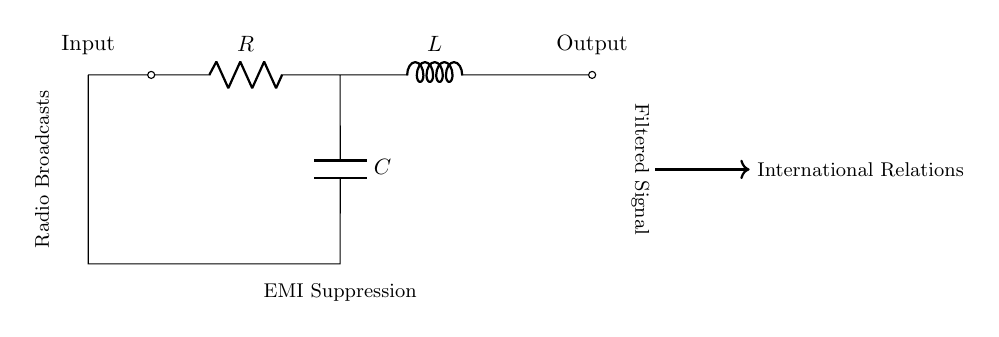What type of filter is represented in this circuit? The circuit diagram represents a low-pass filter, which allows low-frequency signals to pass while attenuating high-frequency signals, making it effective for reducing electromagnetic interference.
Answer: low-pass filter What components are present in the circuit? The circuit includes a resistor, inductor, and capacitor, which are the essential elements used to create a low-pass filter. Each plays a role in determining the filter's frequency characteristics.
Answer: resistor, inductor, capacitor What is the intended purpose of this circuit? The circuit is designed for EMI suppression, which refers to reducing electromagnetic interference in radio broadcasts related to international relations, ensuring clearer signal transmission.
Answer: EMI suppression Where does the filtered signal exit the circuit? The filtered signal exits on the right side of the diagram, shown at the output terminal, which is marked 'Output,' indicating where the processed signal can be taken for further use.
Answer: Output What effect does the inductor have in this filter? The inductor in the circuit opposes changes in current, which helps to block high-frequency signals from passing through, thereby facilitating the filter's ability to allow only low frequencies to pass.
Answer: block high-frequency signals What is typically connected to the input of this filter? The input of this filter would typically be connected to a source of radio broadcasts, which may carry unwanted high-frequency noise that the filter aims to attenuate before processing the signal further.
Answer: radio broadcasts How does the capacitor contribute to this circuit's function? The capacitor allows alternating current (AC) signals to pass while blocking direct current (DC), critically aiding in the filter's ability to target and mitigate unwanted high-frequency interference while allowing low frequencies through.
Answer: block DC 